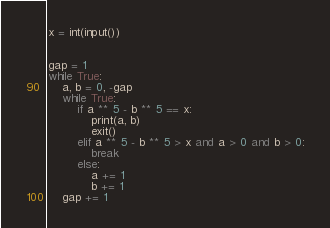<code> <loc_0><loc_0><loc_500><loc_500><_Python_>x = int(input())


gap = 1
while True:
    a, b = 0, -gap
    while True:
        if a ** 5 - b ** 5 == x:
            print(a, b)
            exit()
        elif a ** 5 - b ** 5 > x and a > 0 and b > 0:
            break
        else:
            a += 1
            b += 1
    gap += 1


</code> 